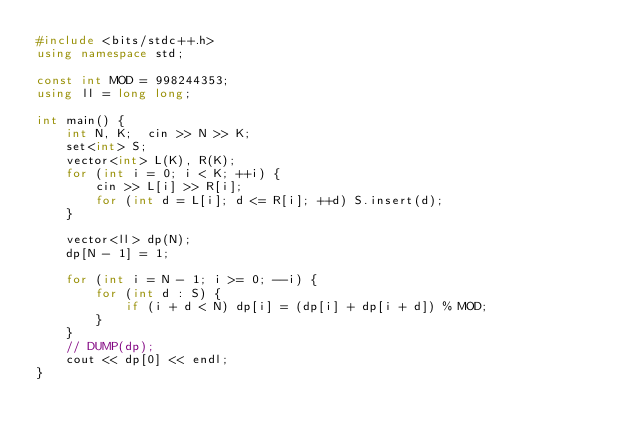<code> <loc_0><loc_0><loc_500><loc_500><_C++_>#include <bits/stdc++.h>
using namespace std;

const int MOD = 998244353;
using ll = long long;

int main() {
    int N, K;  cin >> N >> K;
    set<int> S;
    vector<int> L(K), R(K);
    for (int i = 0; i < K; ++i) {
        cin >> L[i] >> R[i];
        for (int d = L[i]; d <= R[i]; ++d) S.insert(d);
    }

    vector<ll> dp(N);
    dp[N - 1] = 1;

    for (int i = N - 1; i >= 0; --i) {
        for (int d : S) {
            if (i + d < N) dp[i] = (dp[i] + dp[i + d]) % MOD;
        }
    }
    // DUMP(dp);
    cout << dp[0] << endl;
}
</code> 